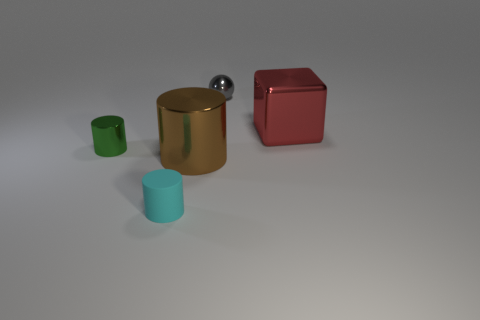What number of objects are large things that are to the left of the block or large cyan rubber spheres?
Offer a very short reply. 1. Are there any red metallic cubes?
Ensure brevity in your answer.  Yes. What material is the object that is right of the gray ball?
Offer a very short reply. Metal. What number of tiny things are gray balls or cyan objects?
Keep it short and to the point. 2. What color is the small metallic cylinder?
Provide a succinct answer. Green. There is a small object behind the shiny cube; is there a tiny cyan rubber cylinder behind it?
Your answer should be very brief. No. Are there fewer red cubes in front of the small cyan thing than yellow things?
Your answer should be compact. No. Is the object that is on the right side of the gray thing made of the same material as the large brown cylinder?
Your response must be concise. Yes. What is the color of the tiny ball that is the same material as the green thing?
Your answer should be compact. Gray. Are there fewer gray balls that are on the left side of the cyan matte thing than metal cylinders that are on the right side of the block?
Make the answer very short. No. 